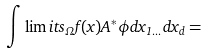Convert formula to latex. <formula><loc_0><loc_0><loc_500><loc_500>\int \lim i t s _ { \Omega } f ( x ) A ^ { \ast } \phi d x _ { 1 \dots } d x _ { d } =</formula> 